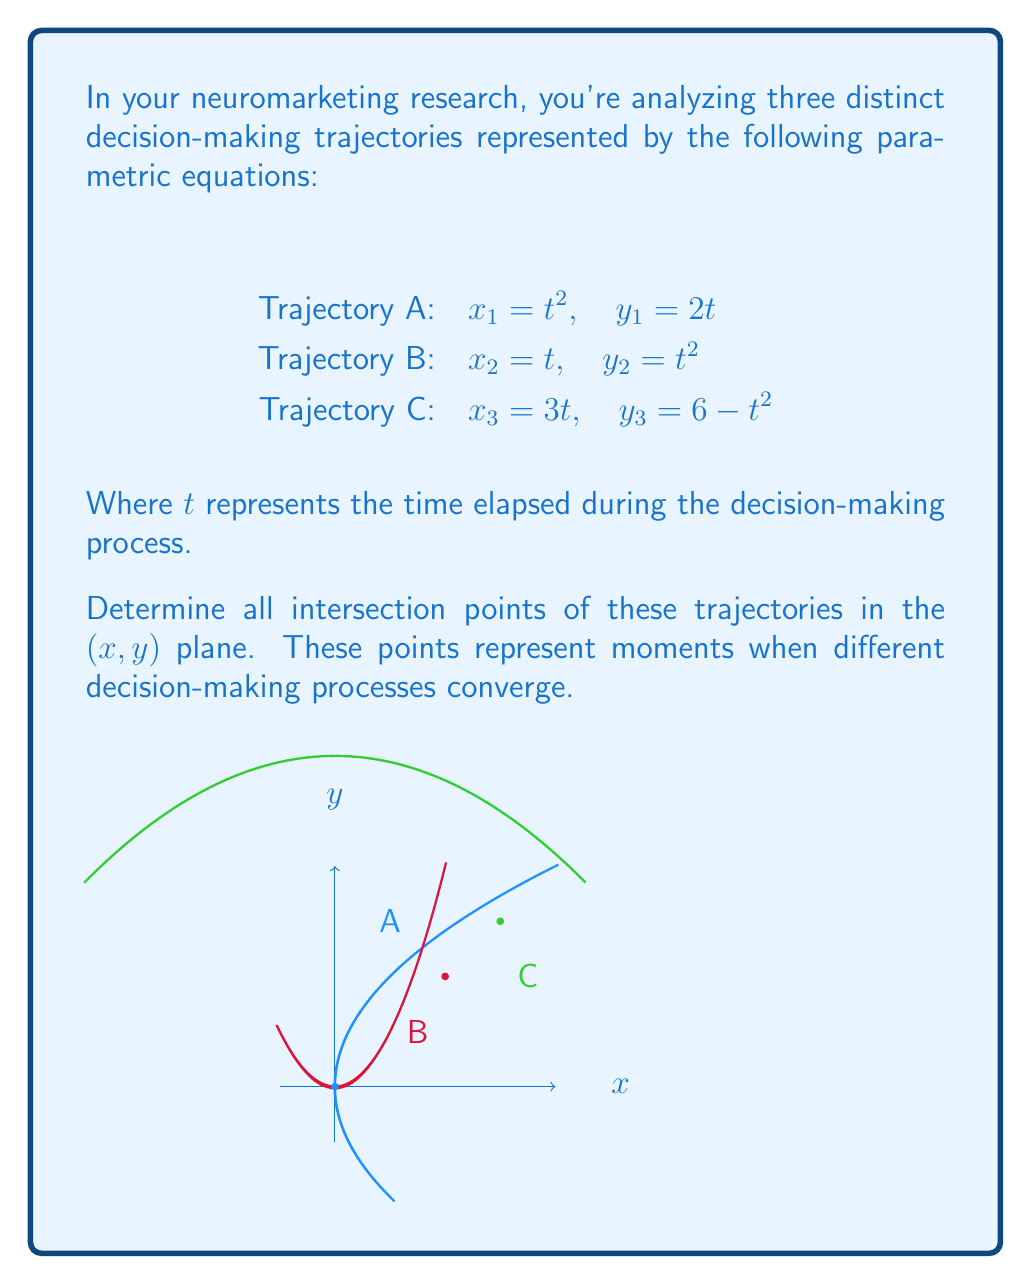Solve this math problem. Let's approach this step-by-step:

1) First, we need to find intersections between trajectories A and B:
   Set $x_1 = x_2$ and $y_1 = y_2$:
   $t^2 = t$ and $2t = t^2$
   From $t^2 = t$, we get $t(t-1) = 0$, so $t = 0$ or $t = 1$
   Checking these in $2t = t^2$:
   For $t = 0$: $0 = 0$ (valid)
   For $t = 1$: $2 = 1$ (not valid)
   So A and B intersect at $(0,0)$ when $t = 0$

2) Now, let's find intersections between trajectories A and C:
   Set $x_1 = x_3$ and $y_1 = y_3$:
   $t^2 = 3t$ and $2t = 6 - t^2$
   From $t^2 = 3t$, we get $t(t-3) = 0$, so $t = 0$ or $t = 3$
   Checking these in $2t = 6 - t^2$:
   For $t = 0$: $0 = 6$ (not valid)
   For $t = 3$: $6 = -3$ (not valid)
   So A and C do not intersect

3) Finally, let's find intersections between trajectories B and C:
   Set $x_2 = x_3$ and $y_2 = y_3$:
   $t = 3t$ and $t^2 = 6 - t^2$
   From $t = 3t$, we get $t = 0$ or $t = 1.5$
   Checking these in $t^2 = 6 - t^2$:
   For $t = 0$: $0 = 6$ (not valid)
   For $t = 1.5$: $2.25 = 3.75$ (not valid)
   So B and C do not intersect

4) The only intersection point we found is $(0,0)$ between trajectories A and B.

5) To verify, we can also check the point $(3,3)$ where trajectories A and B seem to intersect graphically:
   For A: When $x_1 = 3$, $t = \sqrt{3}$, and $y_1 = 2\sqrt{3} \approx 3.46$
   For B: When $x_2 = 3$, $t = 3$, and $y_2 = 9$
   So $(3,3)$ is not an actual intersection point.
Answer: $\{(0,0)\}$ 